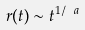Convert formula to latex. <formula><loc_0><loc_0><loc_500><loc_500>r ( t ) \sim t ^ { 1 / \ a }</formula> 